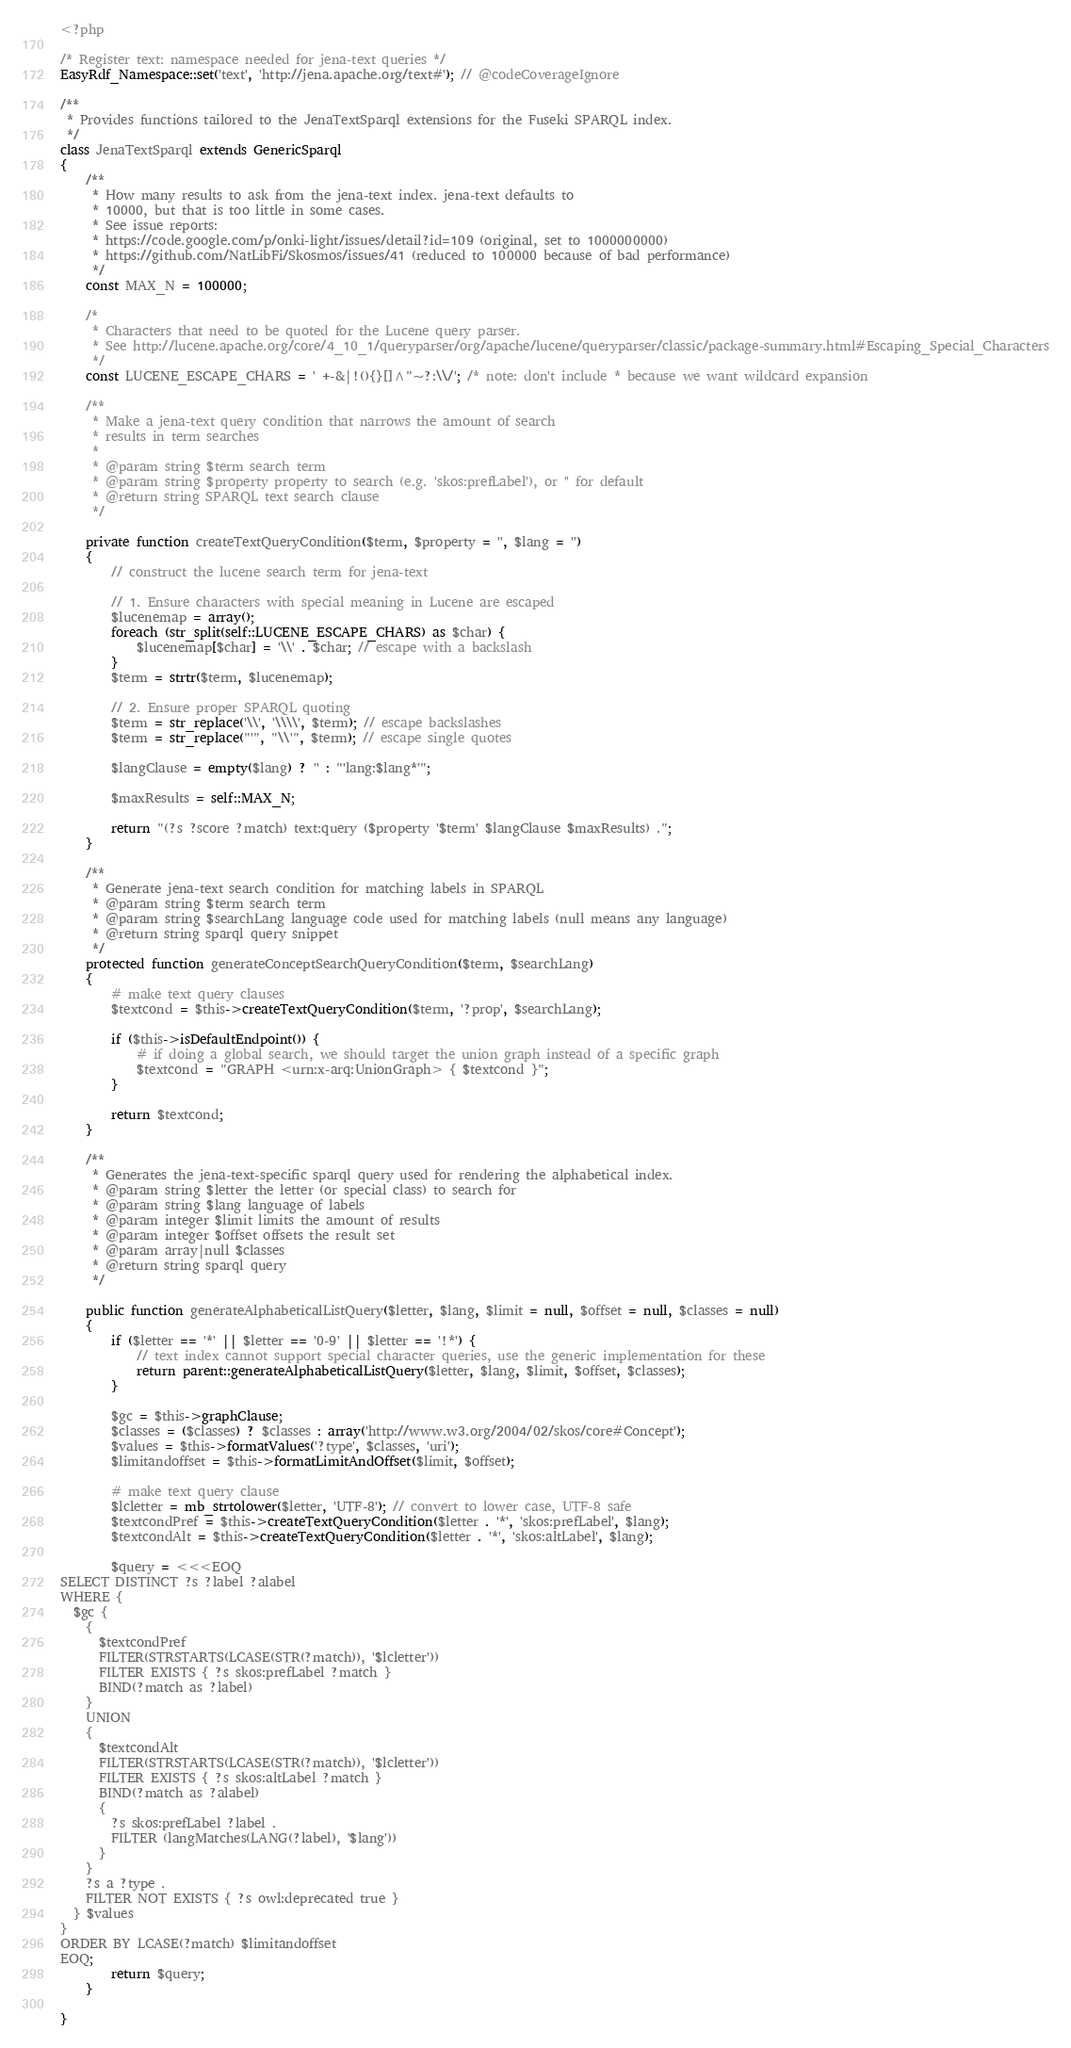<code> <loc_0><loc_0><loc_500><loc_500><_PHP_><?php

/* Register text: namespace needed for jena-text queries */
EasyRdf_Namespace::set('text', 'http://jena.apache.org/text#'); // @codeCoverageIgnore

/**
 * Provides functions tailored to the JenaTextSparql extensions for the Fuseki SPARQL index.
 */
class JenaTextSparql extends GenericSparql
{
    /**
     * How many results to ask from the jena-text index. jena-text defaults to
     * 10000, but that is too little in some cases.
     * See issue reports:
     * https://code.google.com/p/onki-light/issues/detail?id=109 (original, set to 1000000000)
     * https://github.com/NatLibFi/Skosmos/issues/41 (reduced to 100000 because of bad performance)
     */
    const MAX_N = 100000;

    /*
     * Characters that need to be quoted for the Lucene query parser.
     * See http://lucene.apache.org/core/4_10_1/queryparser/org/apache/lucene/queryparser/classic/package-summary.html#Escaping_Special_Characters
     */
    const LUCENE_ESCAPE_CHARS = ' +-&|!(){}[]^"~?:\\/'; /* note: don't include * because we want wildcard expansion

    /**
     * Make a jena-text query condition that narrows the amount of search
     * results in term searches
     *
     * @param string $term search term
     * @param string $property property to search (e.g. 'skos:prefLabel'), or '' for default
     * @return string SPARQL text search clause
     */

    private function createTextQueryCondition($term, $property = '', $lang = '')
    {
        // construct the lucene search term for jena-text

        // 1. Ensure characters with special meaning in Lucene are escaped
        $lucenemap = array();
        foreach (str_split(self::LUCENE_ESCAPE_CHARS) as $char) {
            $lucenemap[$char] = '\\' . $char; // escape with a backslash
        }
        $term = strtr($term, $lucenemap);

        // 2. Ensure proper SPARQL quoting
        $term = str_replace('\\', '\\\\', $term); // escape backslashes
        $term = str_replace("'", "\\'", $term); // escape single quotes

        $langClause = empty($lang) ? '' : "'lang:$lang*'";

        $maxResults = self::MAX_N;

        return "(?s ?score ?match) text:query ($property '$term' $langClause $maxResults) .";
    }

    /**
     * Generate jena-text search condition for matching labels in SPARQL
     * @param string $term search term
     * @param string $searchLang language code used for matching labels (null means any language)
     * @return string sparql query snippet
     */
    protected function generateConceptSearchQueryCondition($term, $searchLang)
    {
        # make text query clauses
        $textcond = $this->createTextQueryCondition($term, '?prop', $searchLang);
        
        if ($this->isDefaultEndpoint()) {
            # if doing a global search, we should target the union graph instead of a specific graph
            $textcond = "GRAPH <urn:x-arq:UnionGraph> { $textcond }";
        }
        
        return $textcond;    
    }

    /**
     * Generates the jena-text-specific sparql query used for rendering the alphabetical index.
     * @param string $letter the letter (or special class) to search for
     * @param string $lang language of labels
     * @param integer $limit limits the amount of results
     * @param integer $offset offsets the result set
     * @param array|null $classes
     * @return string sparql query
     */

    public function generateAlphabeticalListQuery($letter, $lang, $limit = null, $offset = null, $classes = null)
    {
        if ($letter == '*' || $letter == '0-9' || $letter == '!*') {
            // text index cannot support special character queries, use the generic implementation for these
            return parent::generateAlphabeticalListQuery($letter, $lang, $limit, $offset, $classes);
        }

        $gc = $this->graphClause;
        $classes = ($classes) ? $classes : array('http://www.w3.org/2004/02/skos/core#Concept');
        $values = $this->formatValues('?type', $classes, 'uri');
        $limitandoffset = $this->formatLimitAndOffset($limit, $offset);

        # make text query clause
        $lcletter = mb_strtolower($letter, 'UTF-8'); // convert to lower case, UTF-8 safe
        $textcondPref = $this->createTextQueryCondition($letter . '*', 'skos:prefLabel', $lang);
        $textcondAlt = $this->createTextQueryCondition($letter . '*', 'skos:altLabel', $lang);

        $query = <<<EOQ
SELECT DISTINCT ?s ?label ?alabel
WHERE {
  $gc {
    {
      $textcondPref
      FILTER(STRSTARTS(LCASE(STR(?match)), '$lcletter'))
      FILTER EXISTS { ?s skos:prefLabel ?match }
      BIND(?match as ?label)
    }
    UNION
    {
      $textcondAlt
      FILTER(STRSTARTS(LCASE(STR(?match)), '$lcletter'))
      FILTER EXISTS { ?s skos:altLabel ?match }
      BIND(?match as ?alabel)
      {
        ?s skos:prefLabel ?label .
        FILTER (langMatches(LANG(?label), '$lang'))
      }
    }
    ?s a ?type .
    FILTER NOT EXISTS { ?s owl:deprecated true }
  } $values
}
ORDER BY LCASE(?match) $limitandoffset
EOQ;
        return $query;
    }

}
</code> 